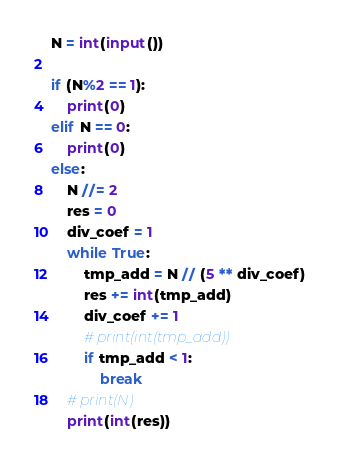Convert code to text. <code><loc_0><loc_0><loc_500><loc_500><_Python_>N = int(input())

if (N%2 == 1):
    print(0)
elif N == 0:
    print(0)
else:
    N //= 2
    res = 0
    div_coef = 1
    while True:
        tmp_add = N // (5 ** div_coef)
        res += int(tmp_add)
        div_coef += 1
        # print(int(tmp_add))
        if tmp_add < 1:
            break
    # print(N)
    print(int(res))
</code> 